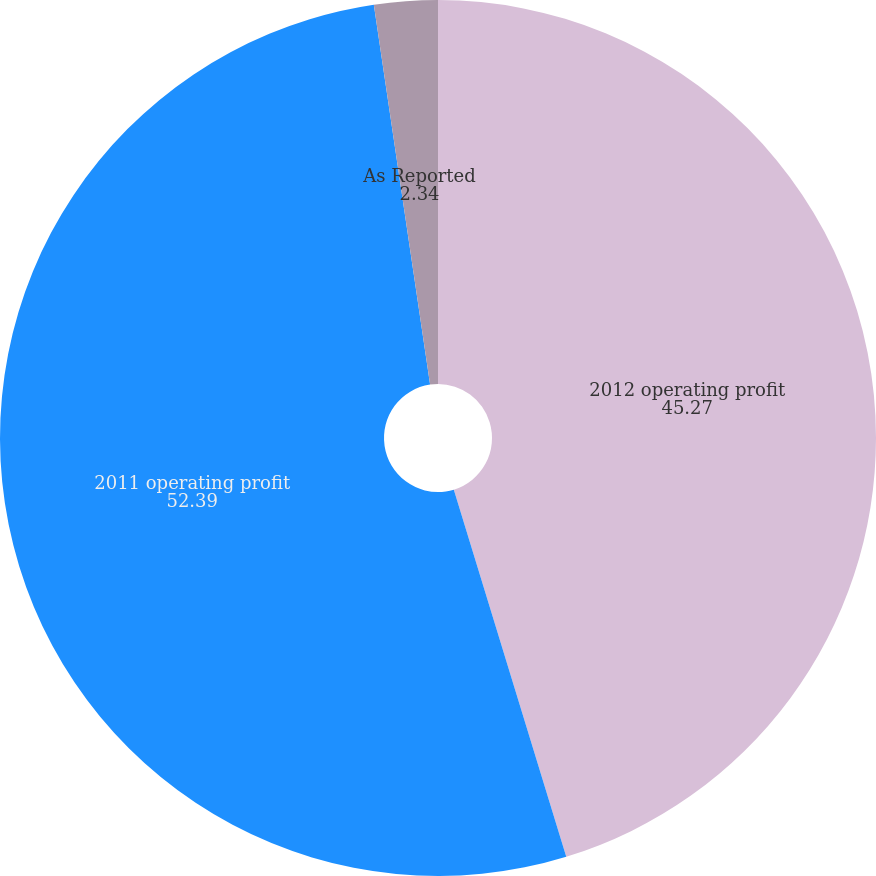Convert chart. <chart><loc_0><loc_0><loc_500><loc_500><pie_chart><fcel>2012 operating profit<fcel>2011 operating profit<fcel>As Reported<nl><fcel>45.27%<fcel>52.39%<fcel>2.34%<nl></chart> 